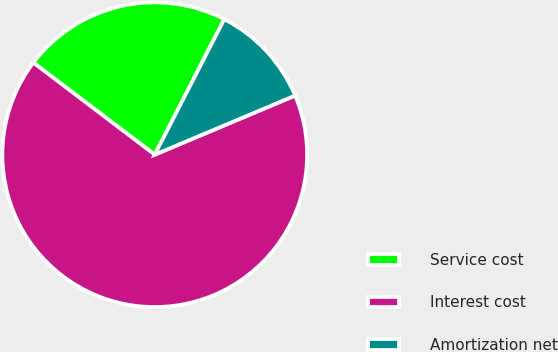Convert chart. <chart><loc_0><loc_0><loc_500><loc_500><pie_chart><fcel>Service cost<fcel>Interest cost<fcel>Amortization net<nl><fcel>22.22%<fcel>66.67%<fcel>11.11%<nl></chart> 